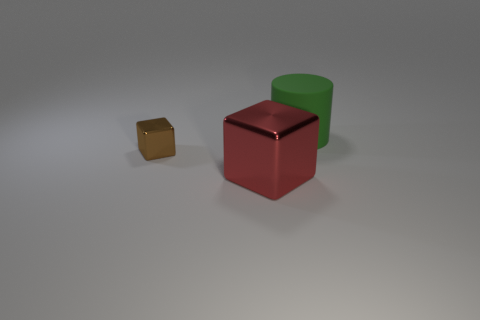Is there anything else that has the same material as the big green object?
Provide a short and direct response. No. There is a big block that is the same material as the small thing; what is its color?
Provide a succinct answer. Red. There is a metal thing that is in front of the metal cube left of the big object in front of the rubber cylinder; what color is it?
Make the answer very short. Red. There is a red metallic object; does it have the same size as the block behind the red thing?
Give a very brief answer. No. What number of objects are either large objects to the left of the big rubber thing or shiny objects that are on the right side of the tiny object?
Make the answer very short. 1. What shape is the shiny object that is the same size as the green matte thing?
Give a very brief answer. Cube. What shape is the red object that is in front of the metallic block that is behind the large object that is in front of the brown metal thing?
Give a very brief answer. Cube. Are there an equal number of large green things that are on the left side of the big metal cube and brown metallic blocks?
Your answer should be very brief. No. Is the size of the brown shiny block the same as the red block?
Give a very brief answer. No. What number of rubber things are either small objects or tiny green objects?
Provide a succinct answer. 0. 